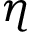<formula> <loc_0><loc_0><loc_500><loc_500>\eta</formula> 